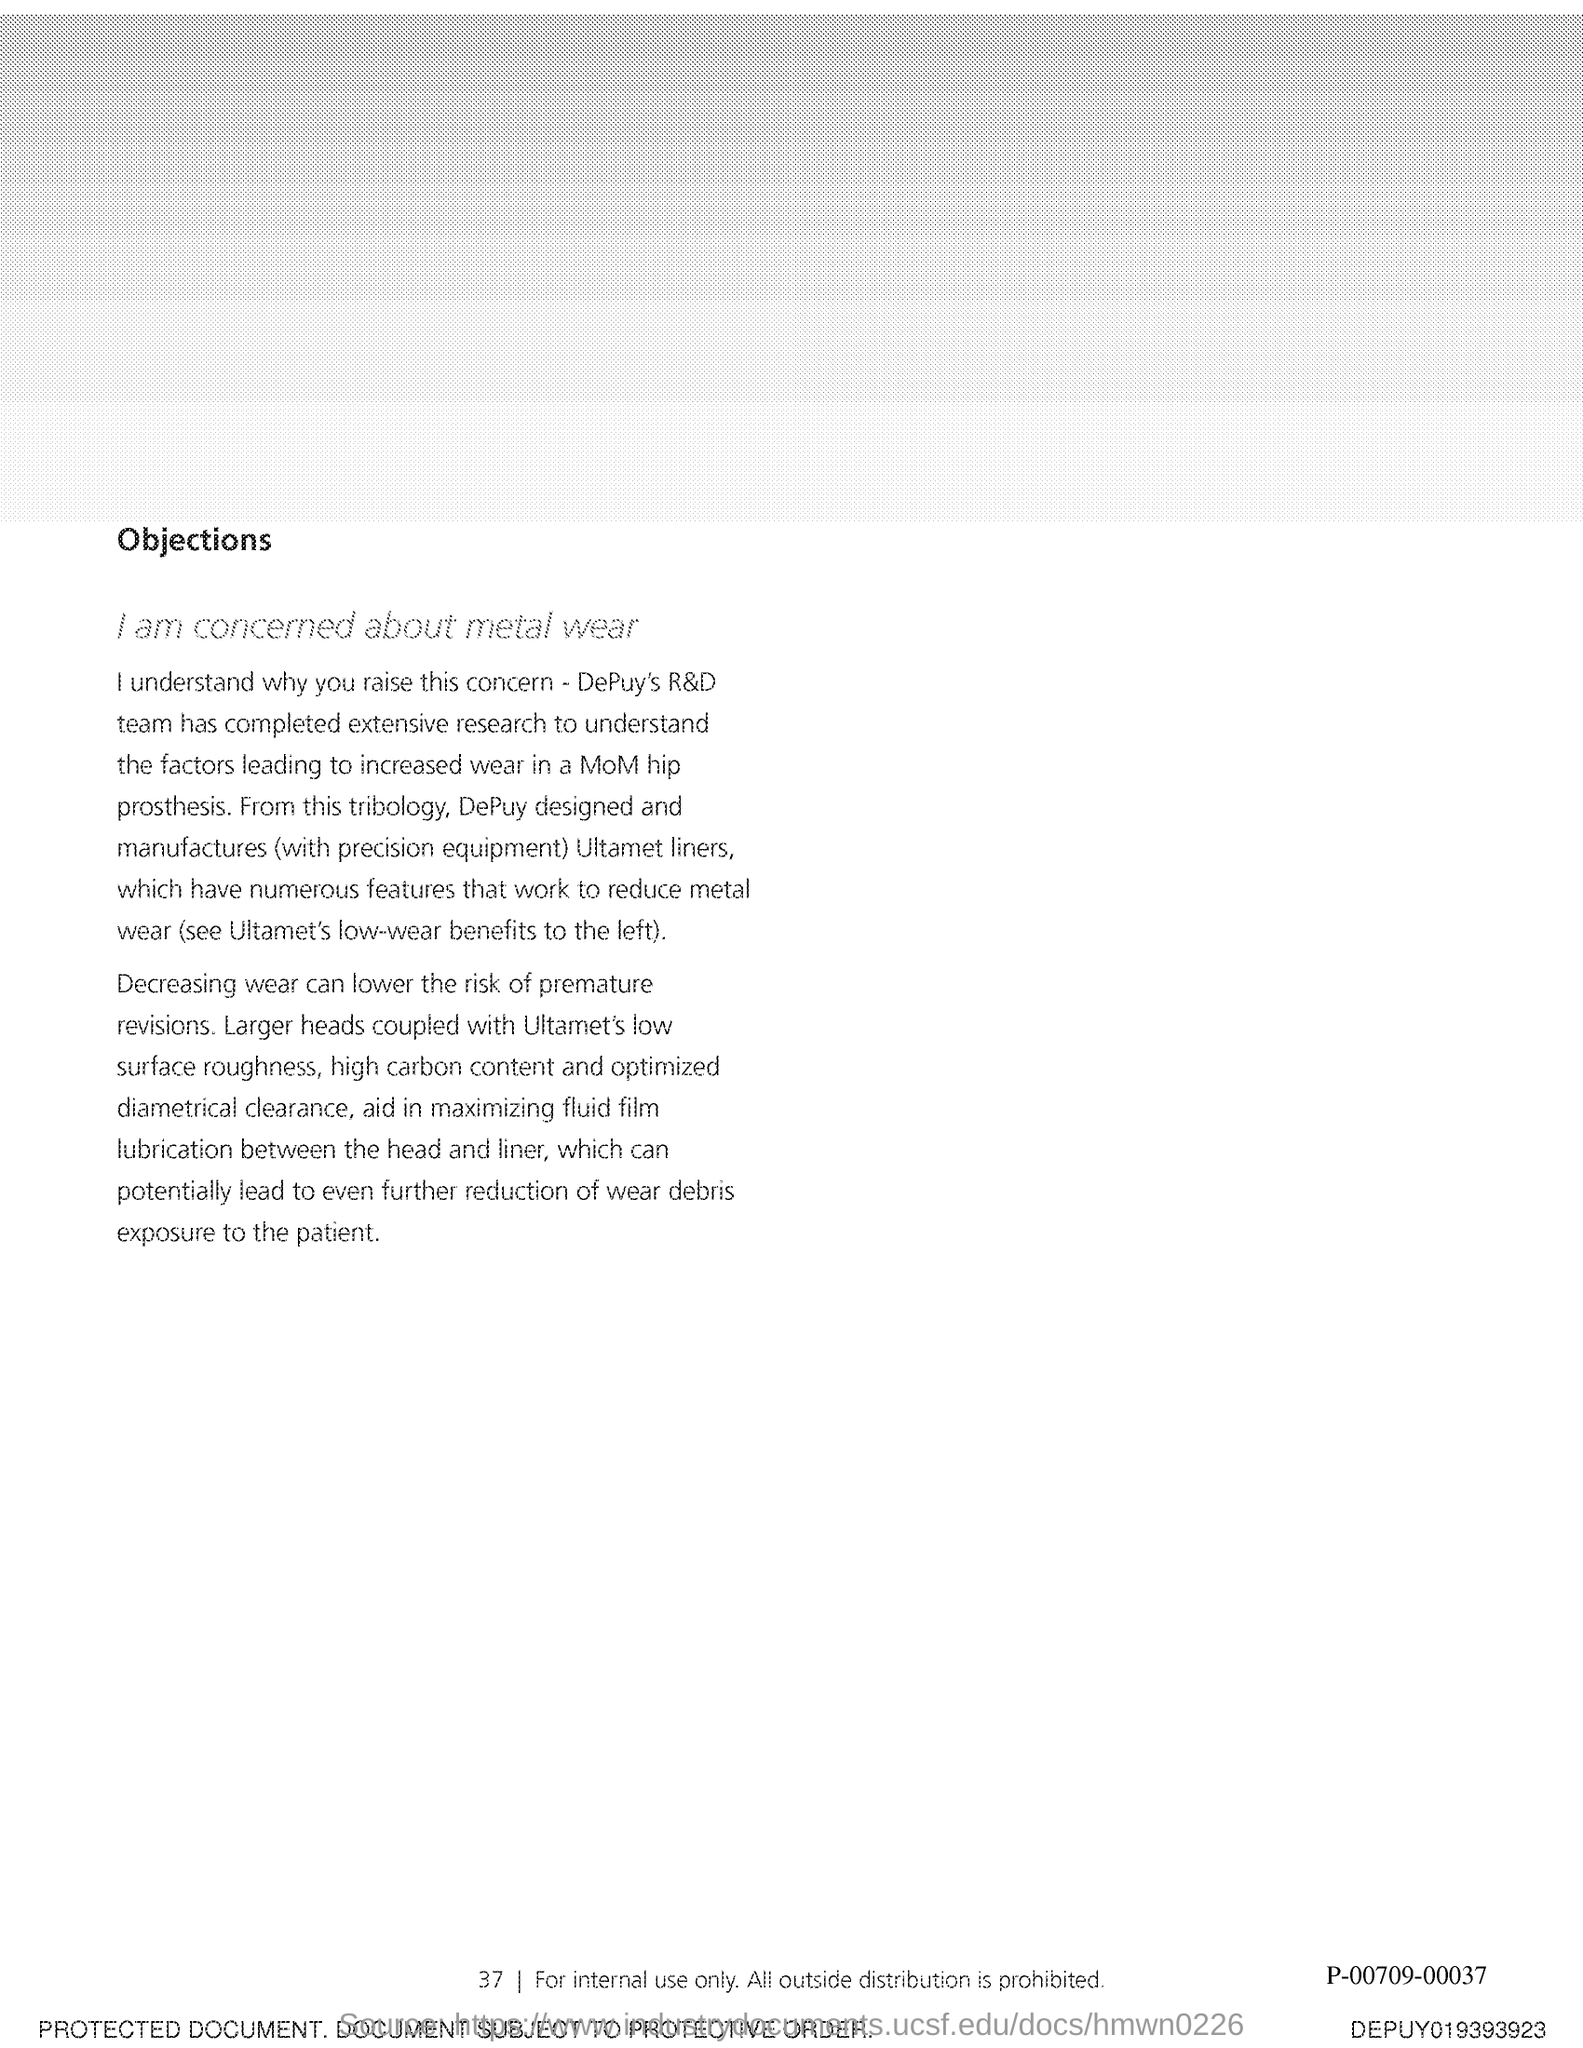List a handful of essential elements in this visual. The second title in this document is concerning metal wear, and I am concerned about it. The first title in this document is 'Objections.' 